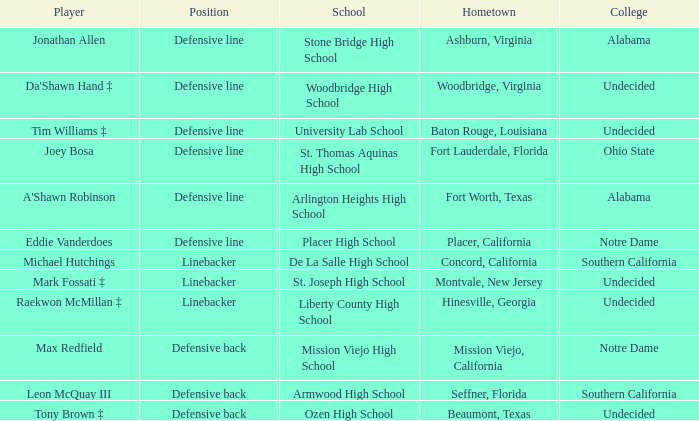What college did the player from Liberty County High School attend? Undecided. 